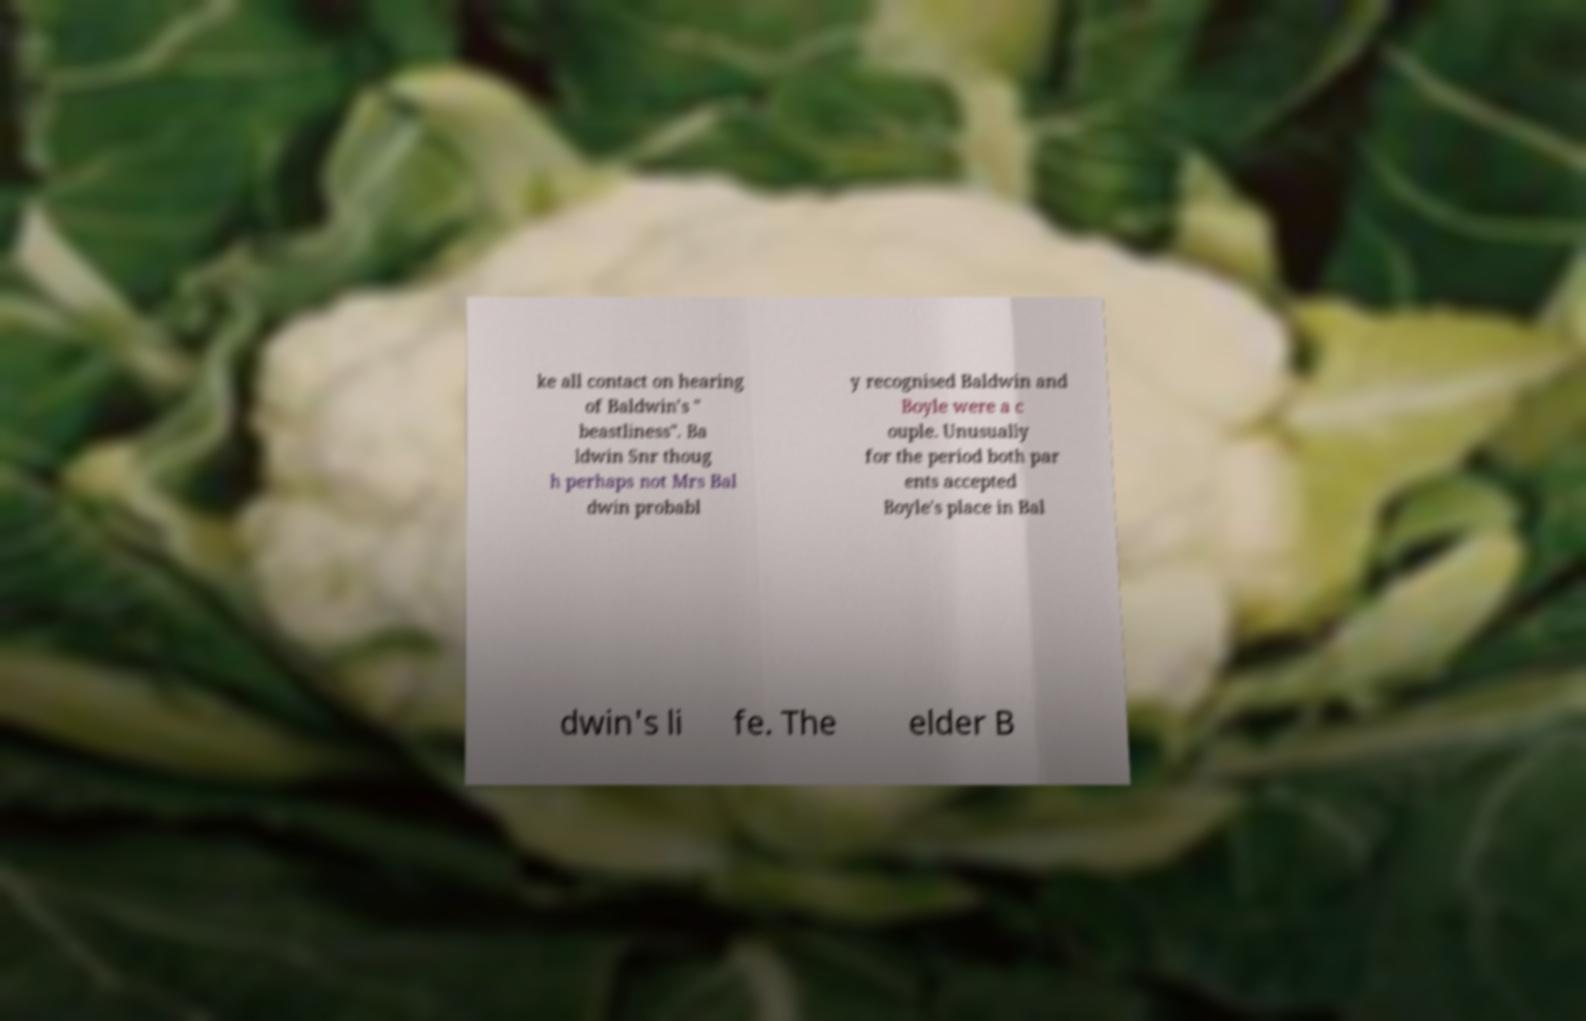Can you accurately transcribe the text from the provided image for me? ke all contact on hearing of Baldwin's " beastliness". Ba ldwin Snr thoug h perhaps not Mrs Bal dwin probabl y recognised Baldwin and Boyle were a c ouple. Unusually for the period both par ents accepted Boyle's place in Bal dwin's li fe. The elder B 